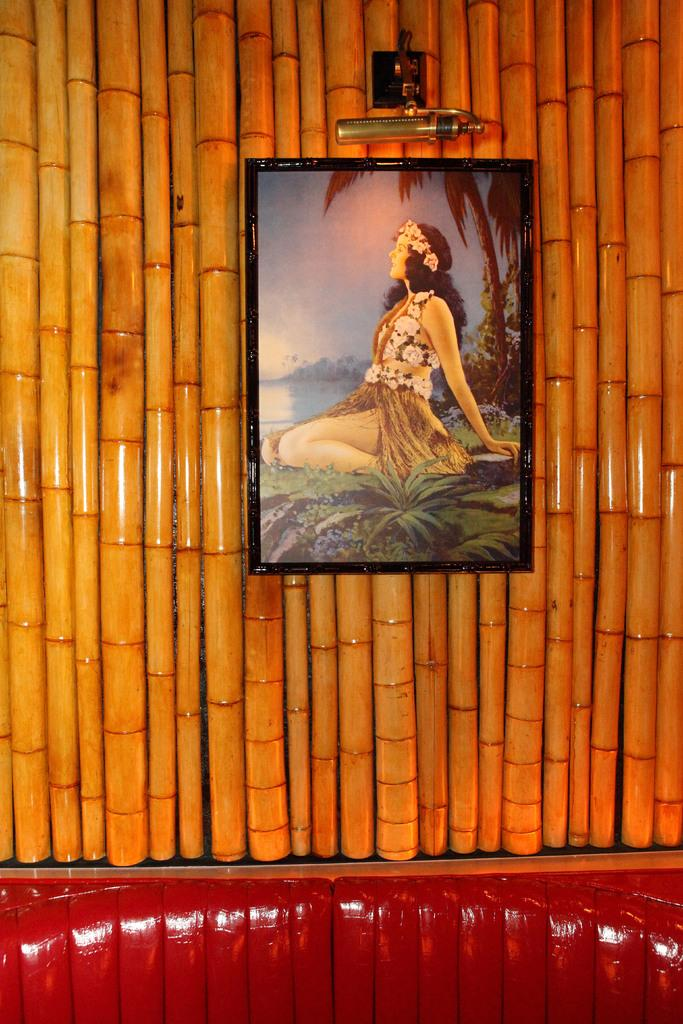What object is present in the image that typically holds a photograph? There is a photo frame in the image. How are the bamboo sticks supporting the photo frame? The bamboo sticks are hanged on bamboo sticks. What color are the bamboo sticks? The bamboo sticks are in cream color. Who is featured in the photograph inside the frame? There is a woman in the photo frame. What type of feast is being prepared in the image? There is no indication of a feast or any food preparation in the image. How many frogs can be seen in the image? There are no frogs present in the image. 